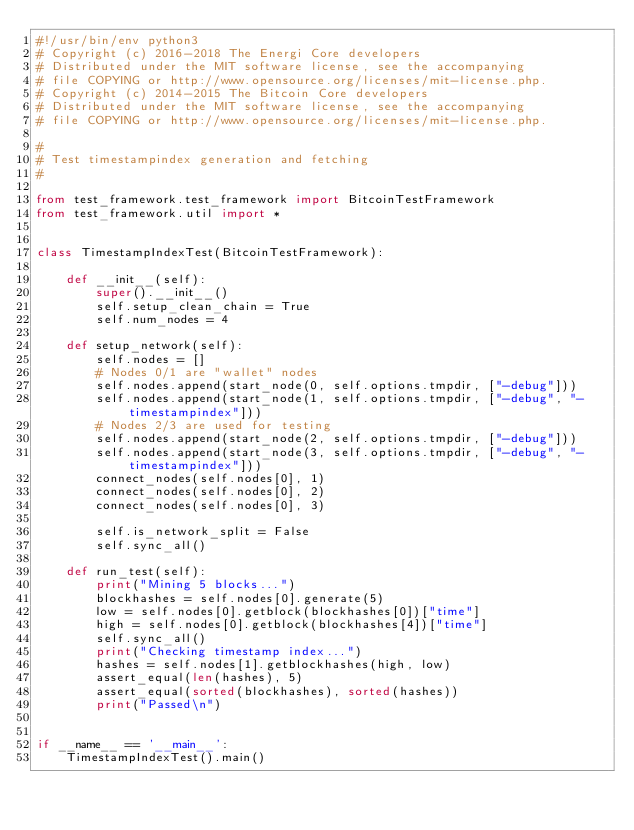<code> <loc_0><loc_0><loc_500><loc_500><_Python_>#!/usr/bin/env python3
# Copyright (c) 2016-2018 The Energi Core developers
# Distributed under the MIT software license, see the accompanying
# file COPYING or http://www.opensource.org/licenses/mit-license.php.
# Copyright (c) 2014-2015 The Bitcoin Core developers
# Distributed under the MIT software license, see the accompanying
# file COPYING or http://www.opensource.org/licenses/mit-license.php.

#
# Test timestampindex generation and fetching
#

from test_framework.test_framework import BitcoinTestFramework
from test_framework.util import *


class TimestampIndexTest(BitcoinTestFramework):

    def __init__(self):
        super().__init__()
        self.setup_clean_chain = True
        self.num_nodes = 4

    def setup_network(self):
        self.nodes = []
        # Nodes 0/1 are "wallet" nodes
        self.nodes.append(start_node(0, self.options.tmpdir, ["-debug"]))
        self.nodes.append(start_node(1, self.options.tmpdir, ["-debug", "-timestampindex"]))
        # Nodes 2/3 are used for testing
        self.nodes.append(start_node(2, self.options.tmpdir, ["-debug"]))
        self.nodes.append(start_node(3, self.options.tmpdir, ["-debug", "-timestampindex"]))
        connect_nodes(self.nodes[0], 1)
        connect_nodes(self.nodes[0], 2)
        connect_nodes(self.nodes[0], 3)

        self.is_network_split = False
        self.sync_all()

    def run_test(self):
        print("Mining 5 blocks...")
        blockhashes = self.nodes[0].generate(5)
        low = self.nodes[0].getblock(blockhashes[0])["time"]
        high = self.nodes[0].getblock(blockhashes[4])["time"]
        self.sync_all()
        print("Checking timestamp index...")
        hashes = self.nodes[1].getblockhashes(high, low)
        assert_equal(len(hashes), 5)
        assert_equal(sorted(blockhashes), sorted(hashes))
        print("Passed\n")


if __name__ == '__main__':
    TimestampIndexTest().main()
</code> 